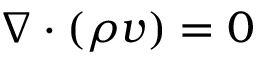Convert formula to latex. <formula><loc_0><loc_0><loc_500><loc_500>\nabla \cdot ( \rho v ) = 0</formula> 